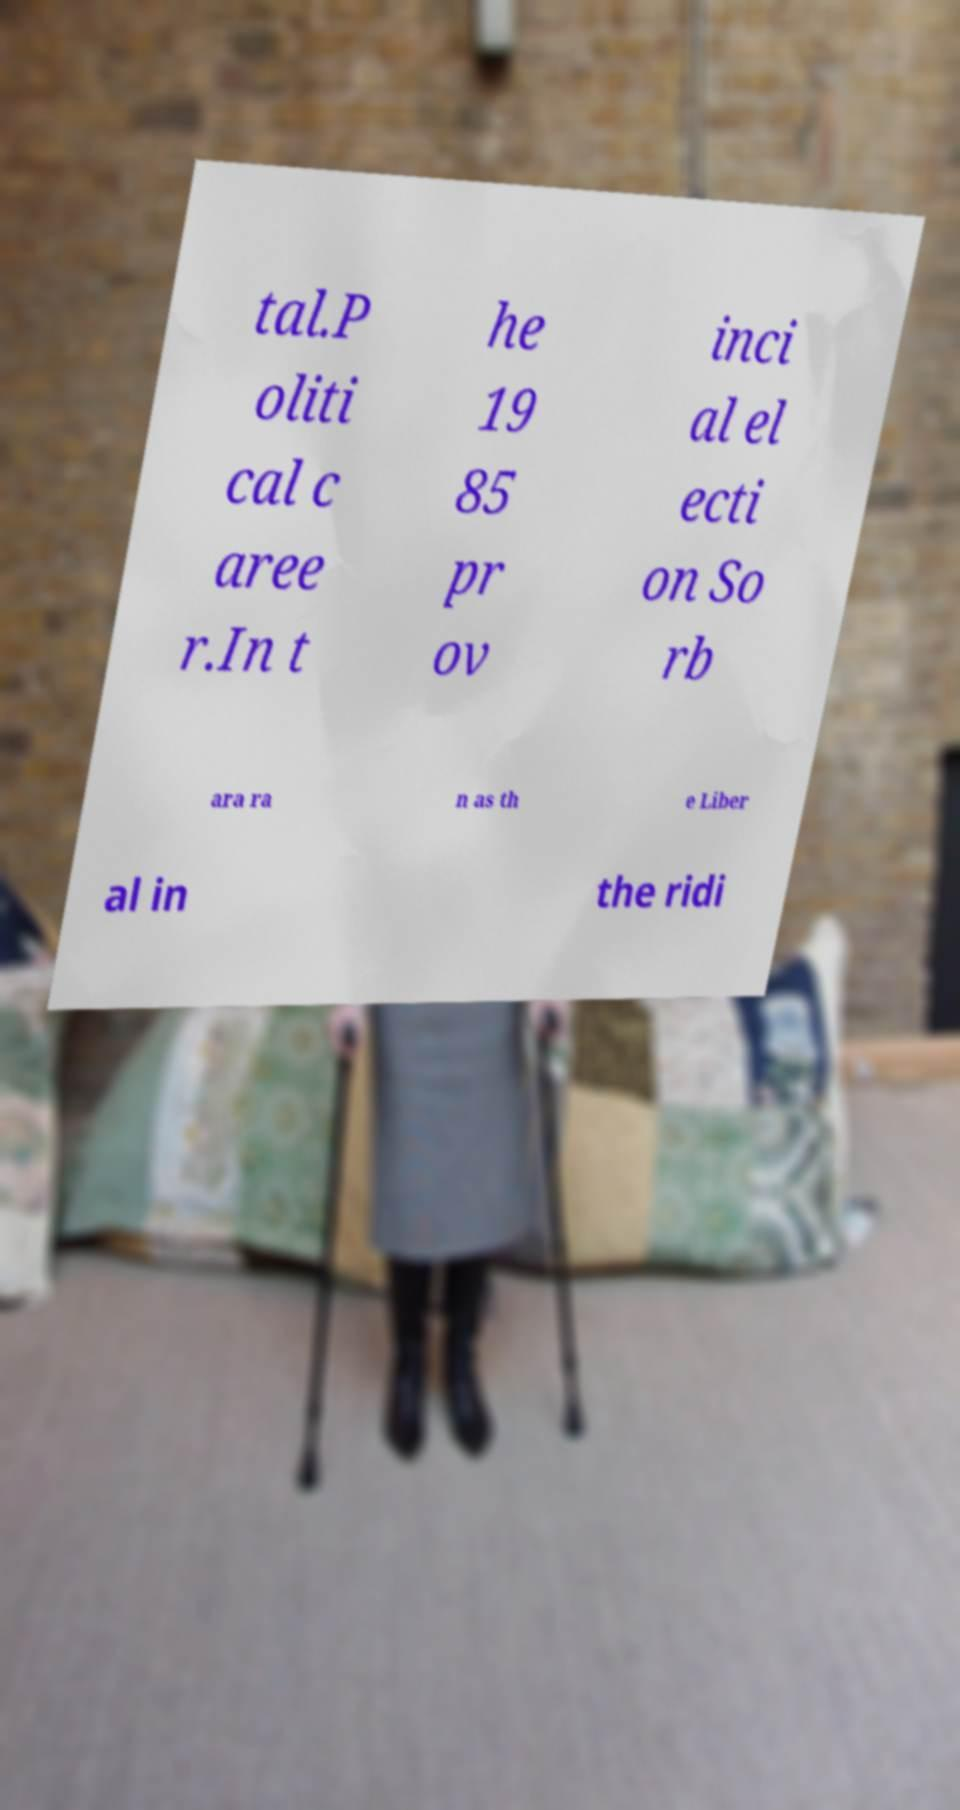For documentation purposes, I need the text within this image transcribed. Could you provide that? tal.P oliti cal c aree r.In t he 19 85 pr ov inci al el ecti on So rb ara ra n as th e Liber al in the ridi 